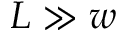<formula> <loc_0><loc_0><loc_500><loc_500>L \gg w</formula> 